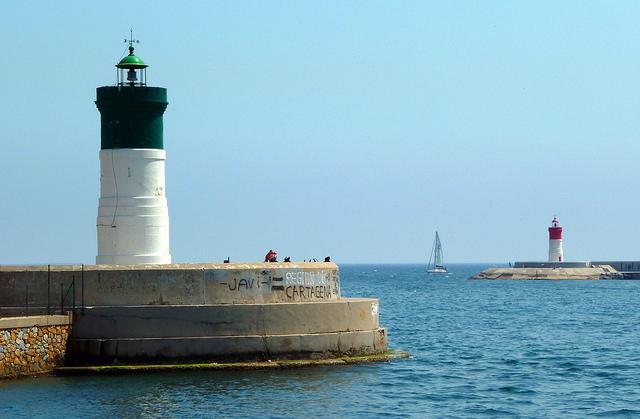How many lighthouses do you see?
Give a very brief answer. 2. Is the water calm?
Be succinct. Yes. Is it a sunny day?
Answer briefly. Yes. 